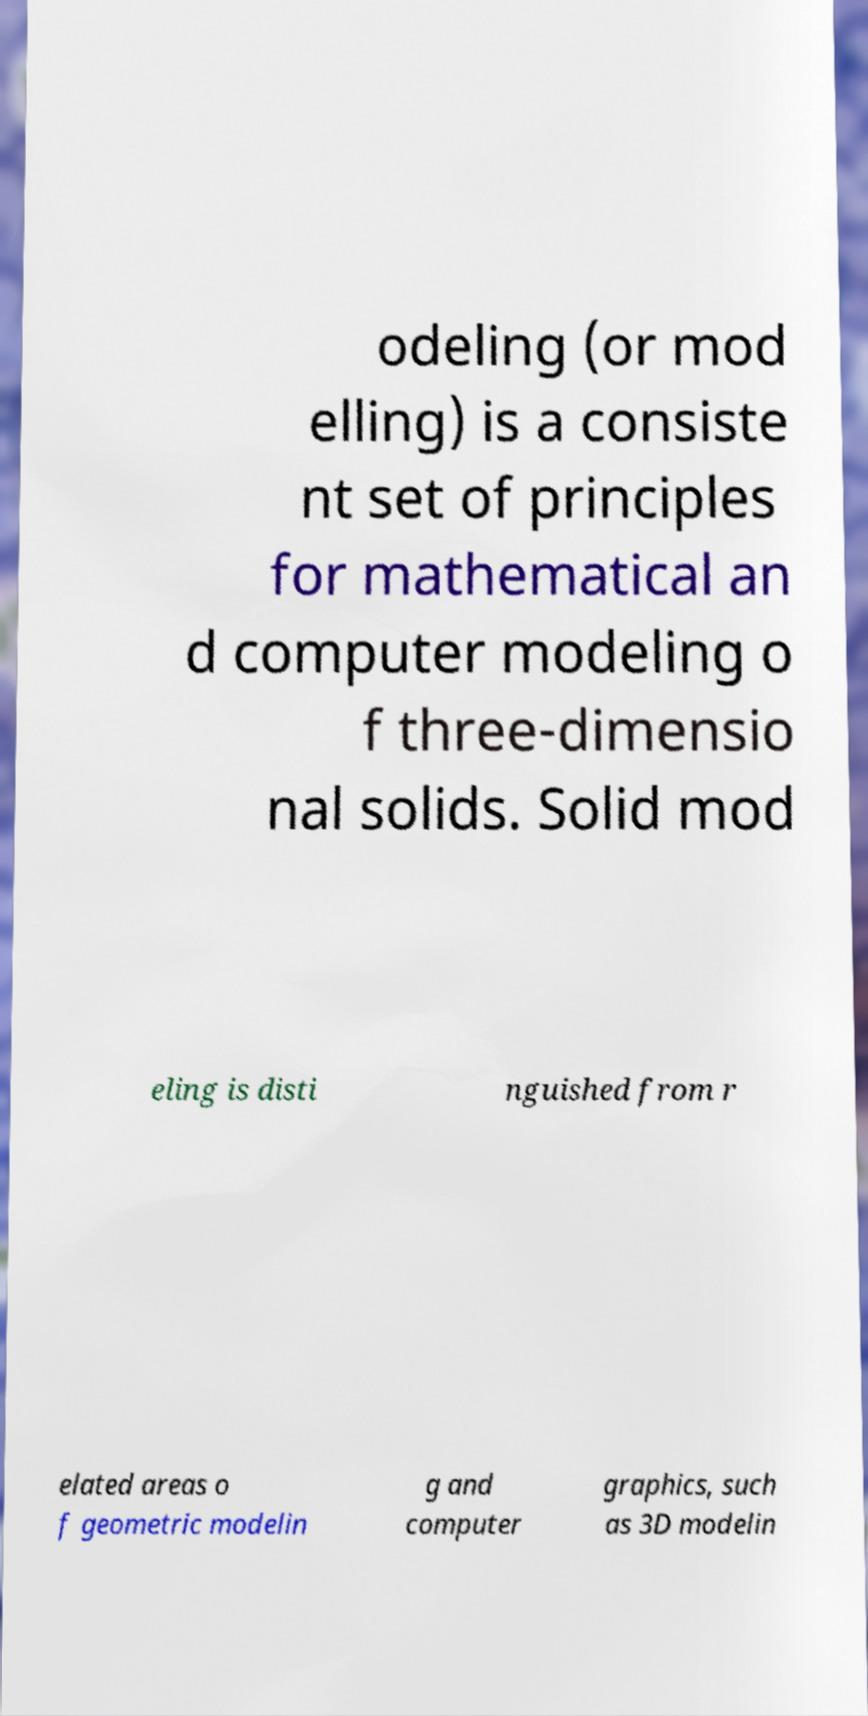There's text embedded in this image that I need extracted. Can you transcribe it verbatim? odeling (or mod elling) is a consiste nt set of principles for mathematical an d computer modeling o f three-dimensio nal solids. Solid mod eling is disti nguished from r elated areas o f geometric modelin g and computer graphics, such as 3D modelin 